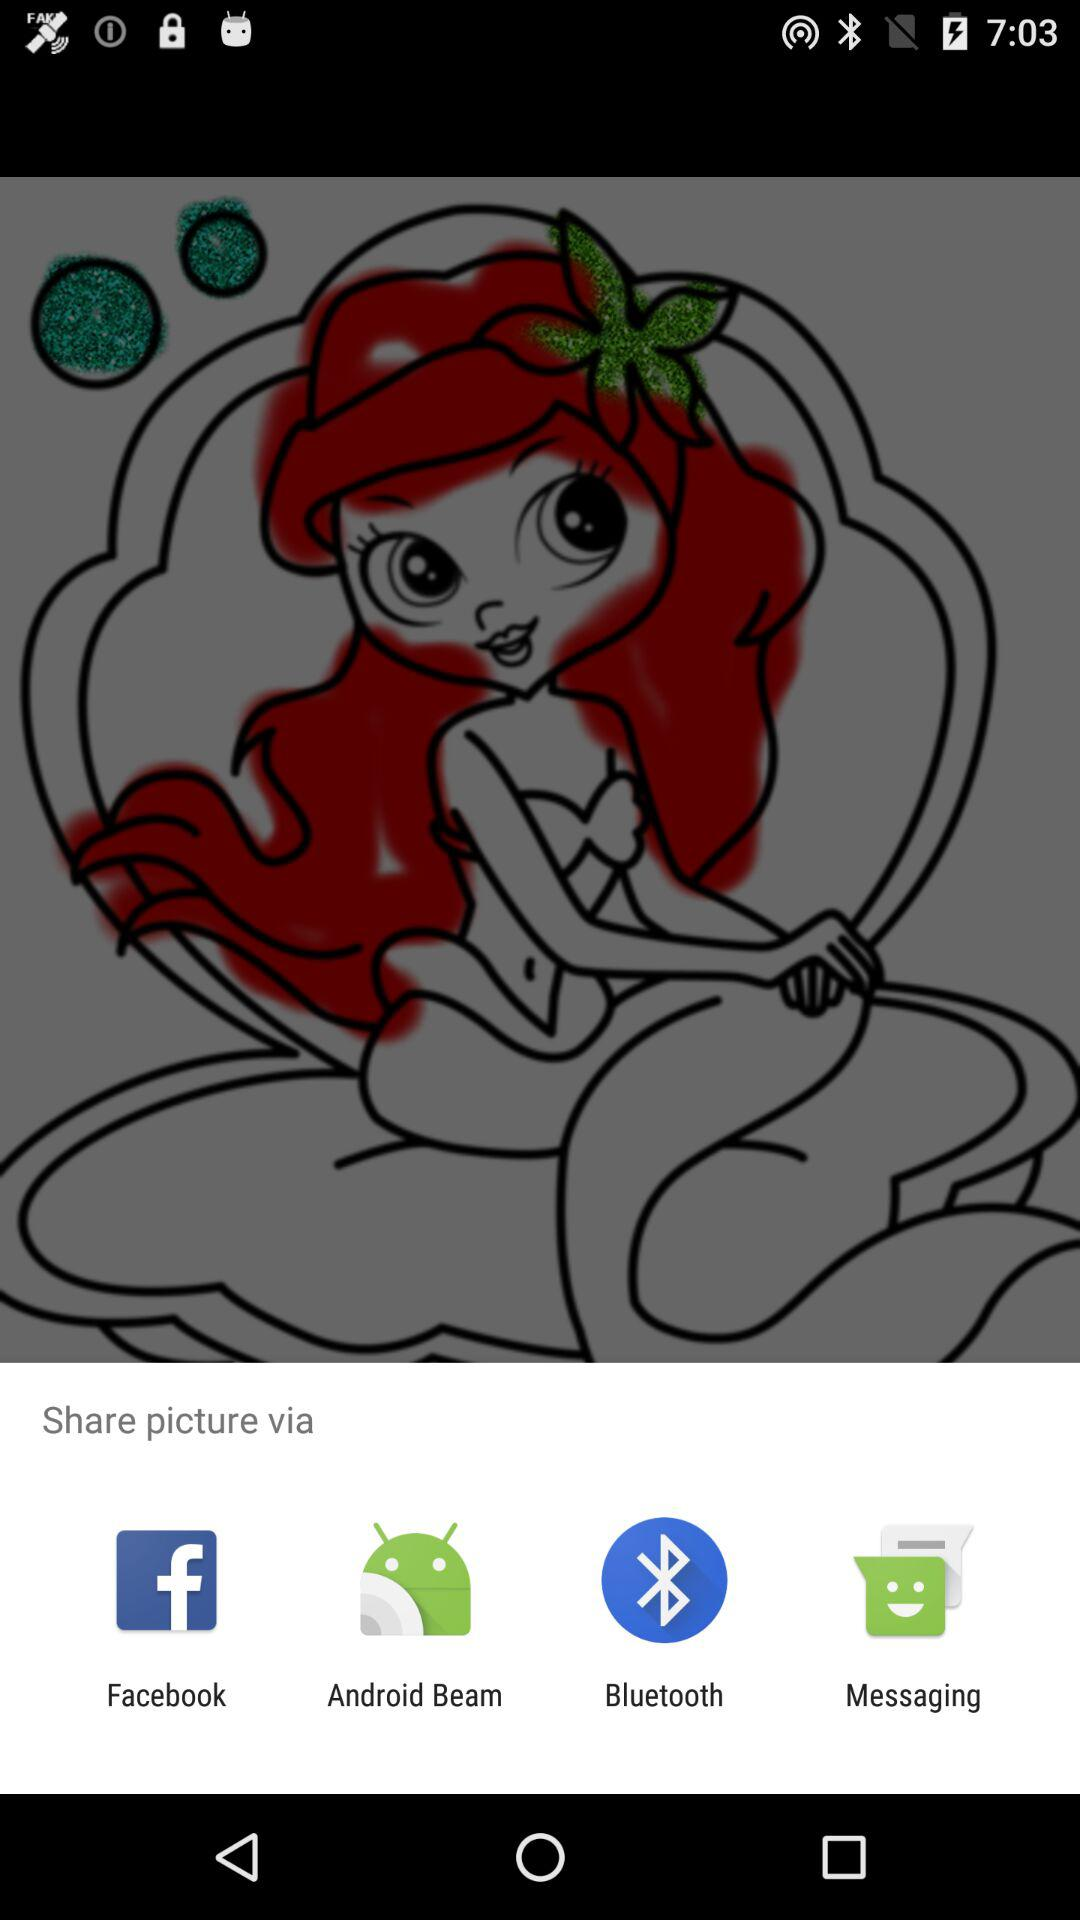How many items are not social media related?
Answer the question using a single word or phrase. 2 